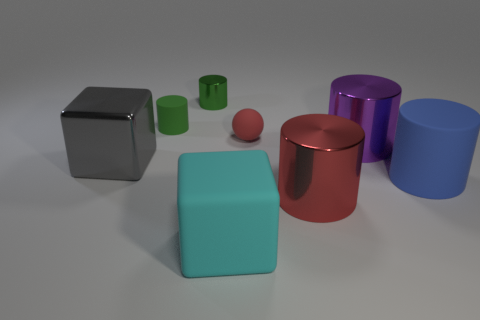Subtract all small shiny cylinders. How many cylinders are left? 4 Subtract all purple cylinders. How many cylinders are left? 4 Add 1 large red cylinders. How many objects exist? 9 Subtract all yellow cylinders. Subtract all red blocks. How many cylinders are left? 5 Subtract all blocks. How many objects are left? 6 Subtract 0 green cubes. How many objects are left? 8 Subtract all tiny red matte blocks. Subtract all tiny spheres. How many objects are left? 7 Add 4 tiny red things. How many tiny red things are left? 5 Add 4 matte things. How many matte things exist? 8 